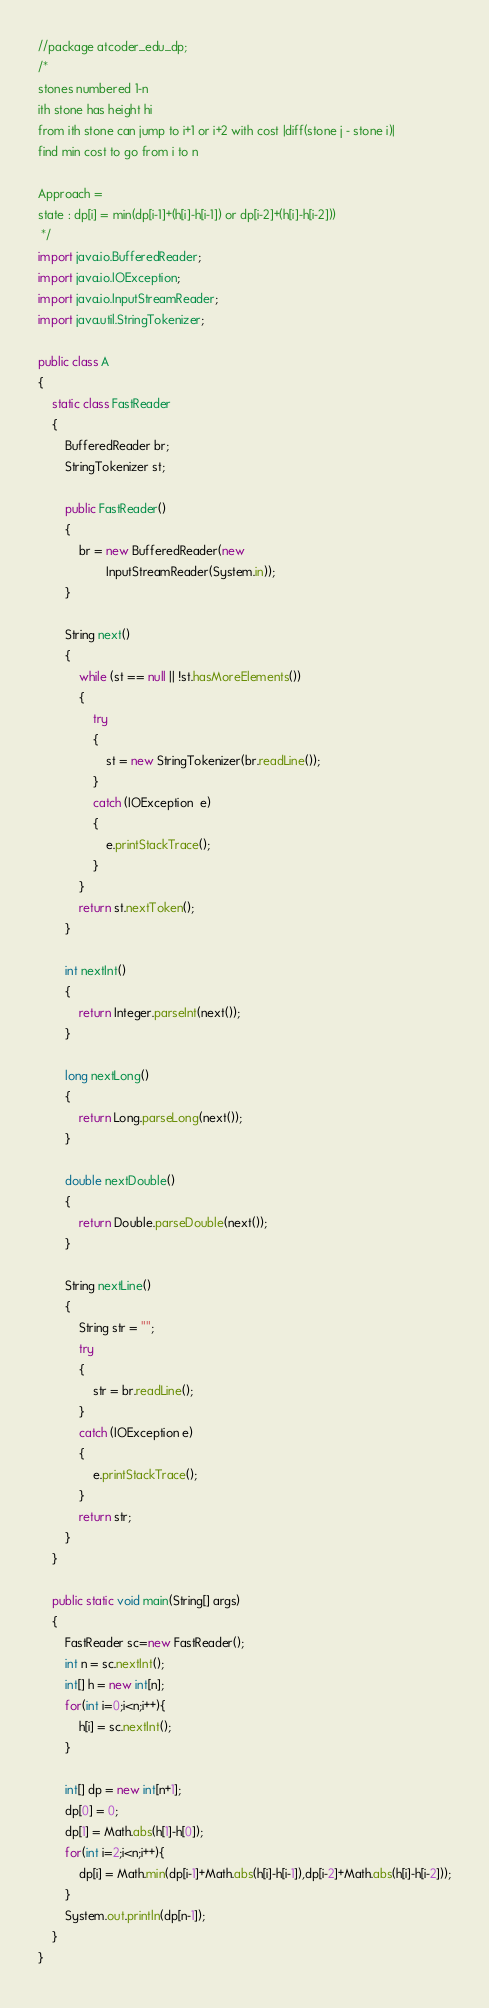Convert code to text. <code><loc_0><loc_0><loc_500><loc_500><_Java_>//package atcoder_edu_dp;
/*
stones numbered 1-n
ith stone has height hi
from ith stone can jump to i+1 or i+2 with cost |diff(stone j - stone i)|
find min cost to go from i to n

Approach =
state : dp[i] = min(dp[i-1]+(h[i]-h[i-1]) or dp[i-2]+(h[i]-h[i-2]))
 */
import java.io.BufferedReader;
import java.io.IOException;
import java.io.InputStreamReader;
import java.util.StringTokenizer;

public class A
{
    static class FastReader
    {
        BufferedReader br;
        StringTokenizer st;

        public FastReader()
        {
            br = new BufferedReader(new
                    InputStreamReader(System.in));
        }

        String next()
        {
            while (st == null || !st.hasMoreElements())
            {
                try
                {
                    st = new StringTokenizer(br.readLine());
                }
                catch (IOException  e)
                {
                    e.printStackTrace();
                }
            }
            return st.nextToken();
        }

        int nextInt()
        {
            return Integer.parseInt(next());
        }

        long nextLong()
        {
            return Long.parseLong(next());
        }

        double nextDouble()
        {
            return Double.parseDouble(next());
        }

        String nextLine()
        {
            String str = "";
            try
            {
                str = br.readLine();
            }
            catch (IOException e)
            {
                e.printStackTrace();
            }
            return str;
        }
    }

    public static void main(String[] args)
    {
        FastReader sc=new FastReader();
        int n = sc.nextInt();
        int[] h = new int[n];
        for(int i=0;i<n;i++){
            h[i] = sc.nextInt();
        }
      
        int[] dp = new int[n+1];
        dp[0] = 0;
        dp[1] = Math.abs(h[1]-h[0]);
        for(int i=2;i<n;i++){
            dp[i] = Math.min(dp[i-1]+Math.abs(h[i]-h[i-1]),dp[i-2]+Math.abs(h[i]-h[i-2]));
        }
        System.out.println(dp[n-1]);
    }
}
</code> 